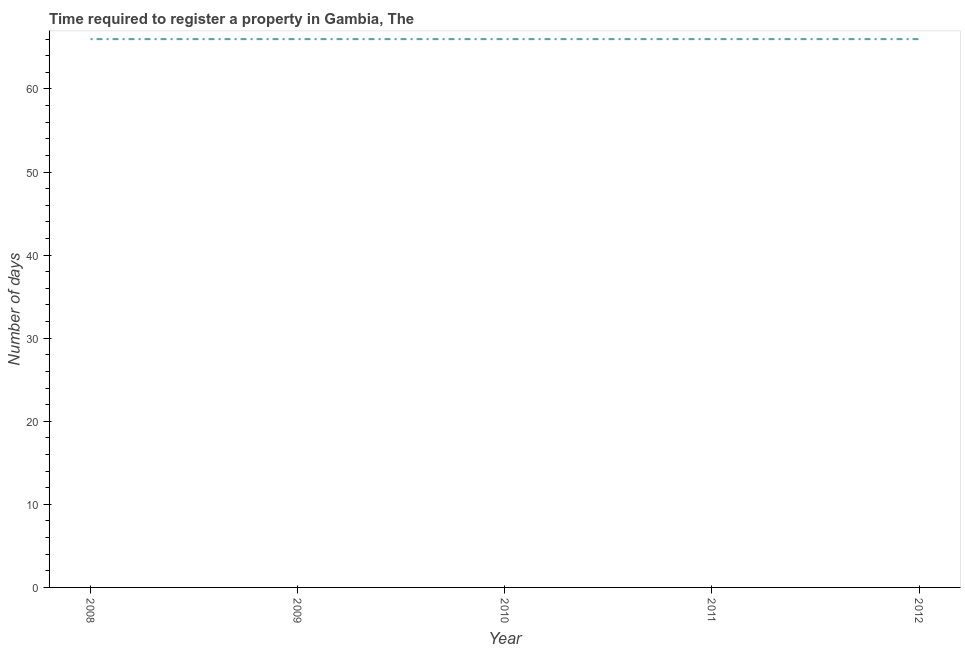What is the number of days required to register property in 2012?
Your answer should be compact. 66. Across all years, what is the maximum number of days required to register property?
Give a very brief answer. 66. Across all years, what is the minimum number of days required to register property?
Keep it short and to the point. 66. In which year was the number of days required to register property maximum?
Your answer should be compact. 2008. In which year was the number of days required to register property minimum?
Your answer should be compact. 2008. What is the sum of the number of days required to register property?
Your answer should be compact. 330. Do a majority of the years between 2011 and 2008 (inclusive) have number of days required to register property greater than 6 days?
Give a very brief answer. Yes. What is the ratio of the number of days required to register property in 2009 to that in 2011?
Provide a succinct answer. 1. Is the number of days required to register property in 2010 less than that in 2012?
Provide a succinct answer. No. What is the difference between the highest and the second highest number of days required to register property?
Your response must be concise. 0. Is the sum of the number of days required to register property in 2010 and 2011 greater than the maximum number of days required to register property across all years?
Your answer should be very brief. Yes. What is the difference between the highest and the lowest number of days required to register property?
Your answer should be very brief. 0. Does the number of days required to register property monotonically increase over the years?
Your answer should be compact. No. How many lines are there?
Give a very brief answer. 1. How many years are there in the graph?
Offer a very short reply. 5. What is the difference between two consecutive major ticks on the Y-axis?
Ensure brevity in your answer.  10. Does the graph contain any zero values?
Provide a succinct answer. No. What is the title of the graph?
Your response must be concise. Time required to register a property in Gambia, The. What is the label or title of the Y-axis?
Your answer should be very brief. Number of days. What is the Number of days of 2008?
Your answer should be very brief. 66. What is the Number of days of 2012?
Your answer should be compact. 66. What is the difference between the Number of days in 2008 and 2009?
Provide a succinct answer. 0. What is the difference between the Number of days in 2008 and 2012?
Provide a succinct answer. 0. What is the difference between the Number of days in 2009 and 2012?
Your answer should be compact. 0. What is the difference between the Number of days in 2010 and 2011?
Your answer should be very brief. 0. What is the difference between the Number of days in 2011 and 2012?
Your response must be concise. 0. What is the ratio of the Number of days in 2008 to that in 2010?
Provide a succinct answer. 1. What is the ratio of the Number of days in 2009 to that in 2010?
Your answer should be very brief. 1. What is the ratio of the Number of days in 2009 to that in 2011?
Provide a succinct answer. 1. What is the ratio of the Number of days in 2010 to that in 2012?
Ensure brevity in your answer.  1. What is the ratio of the Number of days in 2011 to that in 2012?
Your response must be concise. 1. 